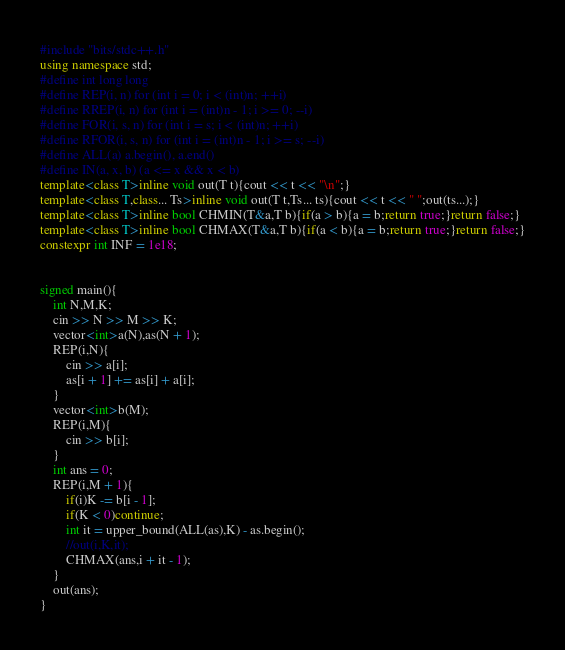Convert code to text. <code><loc_0><loc_0><loc_500><loc_500><_C++_>#include "bits/stdc++.h"
using namespace std;
#define int long long
#define REP(i, n) for (int i = 0; i < (int)n; ++i)
#define RREP(i, n) for (int i = (int)n - 1; i >= 0; --i)
#define FOR(i, s, n) for (int i = s; i < (int)n; ++i)
#define RFOR(i, s, n) for (int i = (int)n - 1; i >= s; --i)
#define ALL(a) a.begin(), a.end()
#define IN(a, x, b) (a <= x && x < b)
template<class T>inline void out(T t){cout << t << "\n";}
template<class T,class... Ts>inline void out(T t,Ts... ts){cout << t << " ";out(ts...);}
template<class T>inline bool CHMIN(T&a,T b){if(a > b){a = b;return true;}return false;}
template<class T>inline bool CHMAX(T&a,T b){if(a < b){a = b;return true;}return false;}
constexpr int INF = 1e18;


signed main(){
	int N,M,K;
	cin >> N >> M >> K;
	vector<int>a(N),as(N + 1);
	REP(i,N){
		cin >> a[i];
		as[i + 1] += as[i] + a[i];
	}
	vector<int>b(M);
	REP(i,M){
		cin >> b[i];
	}
	int ans = 0;
	REP(i,M + 1){
		if(i)K -= b[i - 1];
		if(K < 0)continue;
		int it = upper_bound(ALL(as),K) - as.begin();
		//out(i,K,it);
		CHMAX(ans,i + it - 1);
	}
	out(ans);
}</code> 